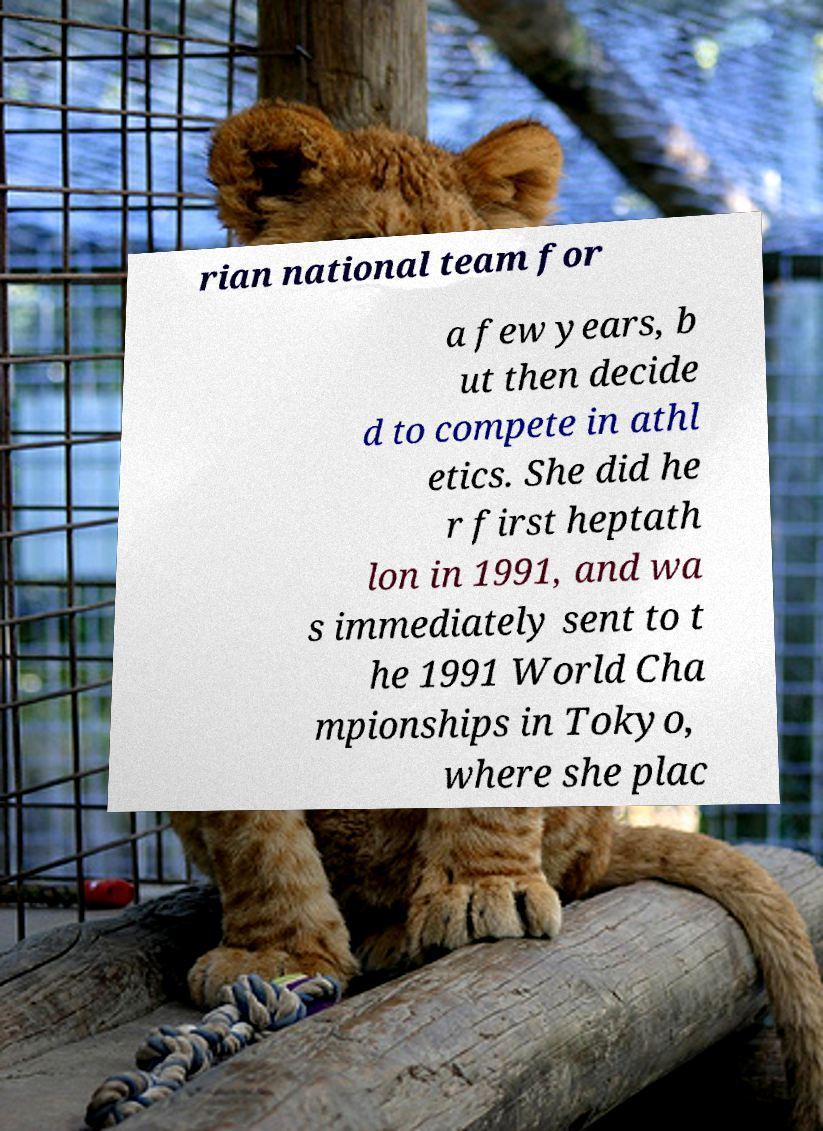Please read and relay the text visible in this image. What does it say? rian national team for a few years, b ut then decide d to compete in athl etics. She did he r first heptath lon in 1991, and wa s immediately sent to t he 1991 World Cha mpionships in Tokyo, where she plac 